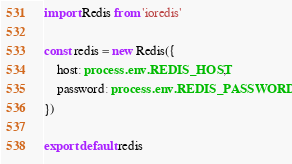Convert code to text. <code><loc_0><loc_0><loc_500><loc_500><_TypeScript_>import Redis from 'ioredis'

const redis = new Redis({
	host: process.env.REDIS_HOST,
	password: process.env.REDIS_PASSWORD
})

export default redis
</code> 